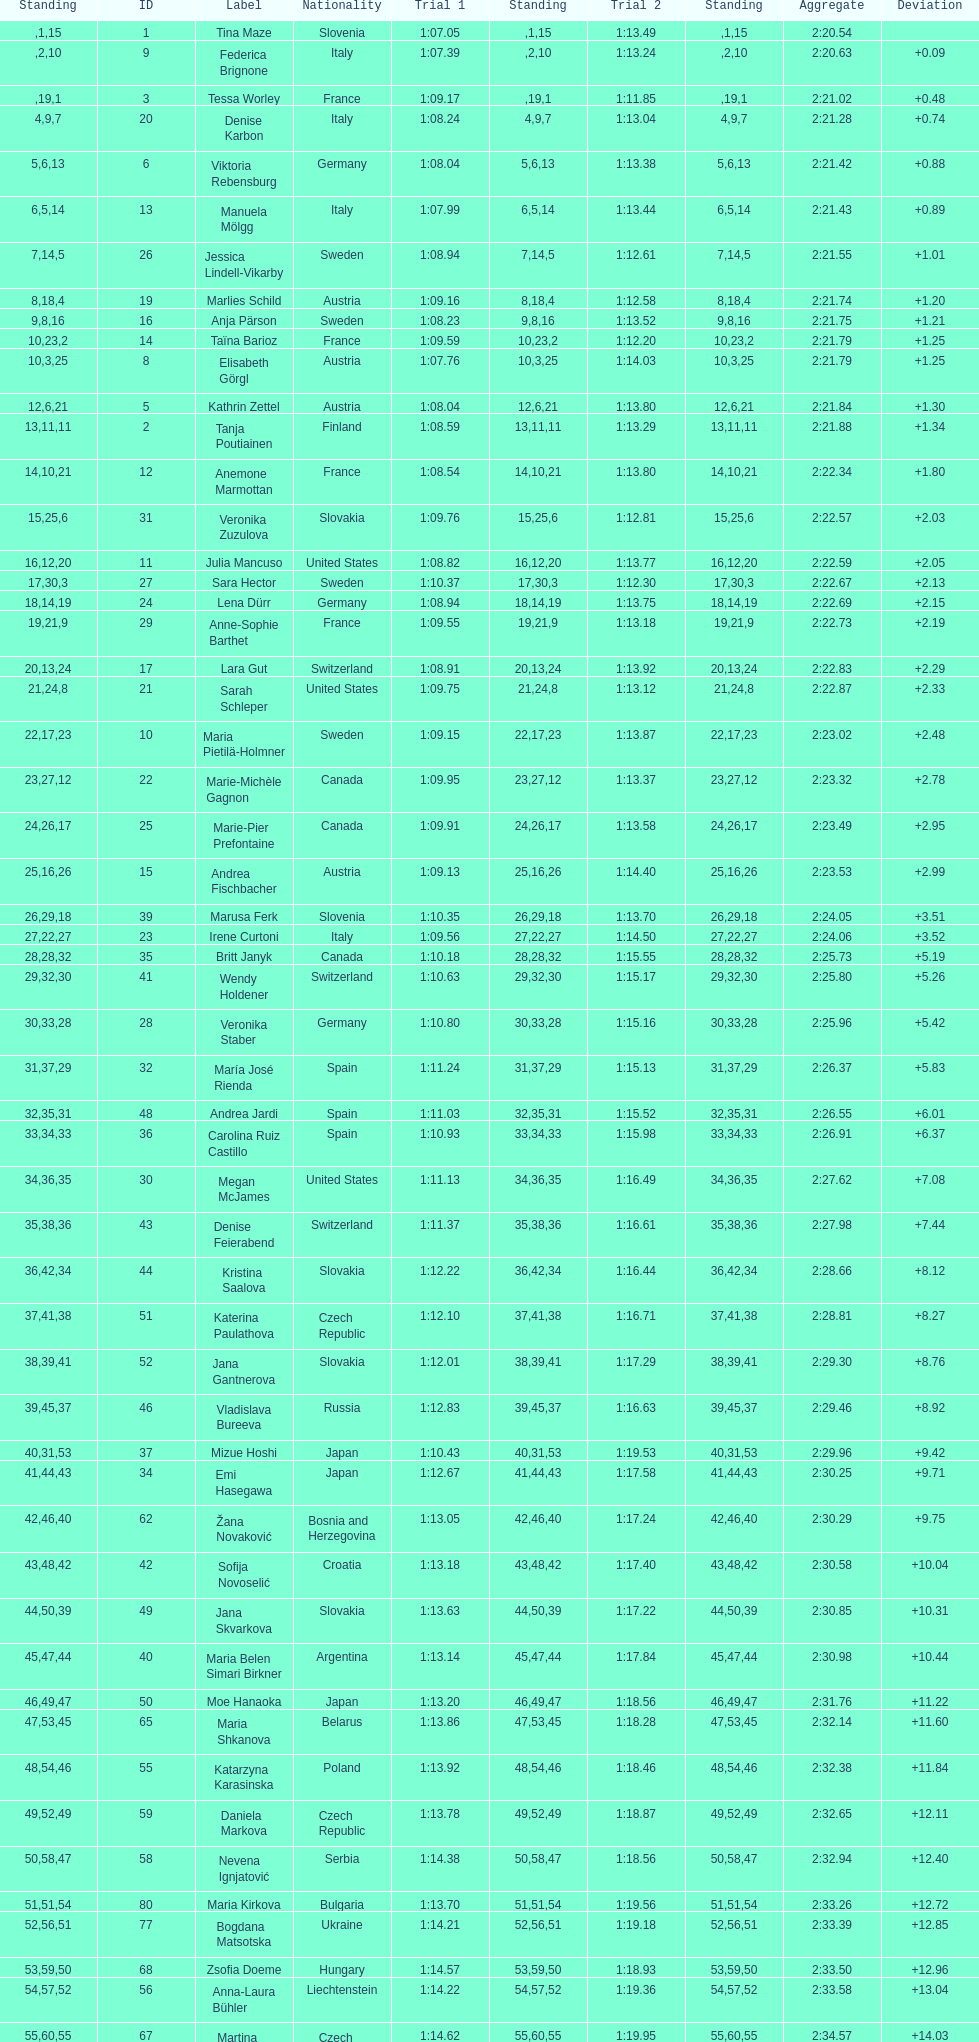How long did it take tina maze to finish the race? 2:20.54. 